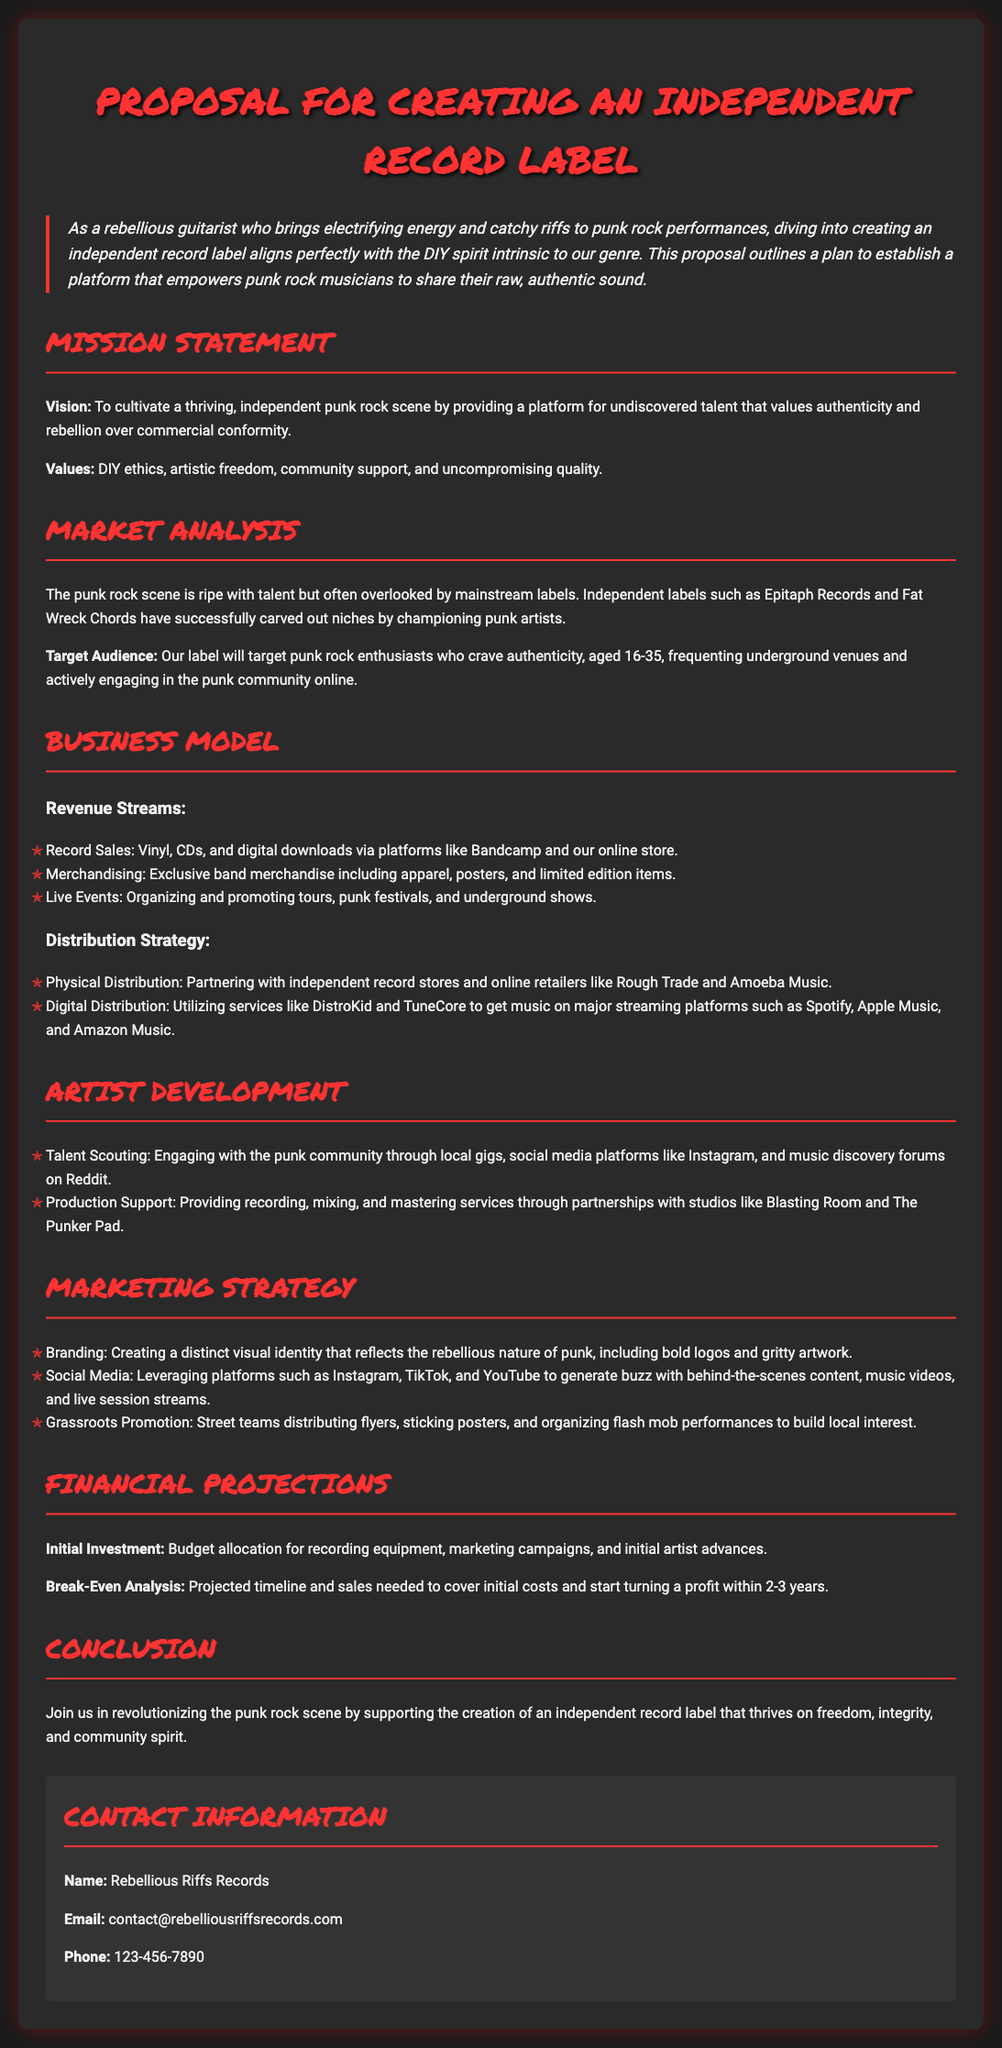What is the main mission of the record label? The mission statement outlines the vision of cultivating an independent punk rock scene with a focus on authenticity and rebellion.
Answer: To cultivate a thriving, independent punk rock scene What are the target audience age range for the label? The document specifies the age range of the target audience looking for authenticity in the punk scene.
Answer: 16-35 Which two independent labels are mentioned in the market analysis? The proposal lists Epitaph Records and Fat Wreck Chords as examples of successful independent labels.
Answer: Epitaph Records and Fat Wreck Chords What revenue stream involves organizing tours and festivals? The business model section specifies that live events generate revenue through organizing and promoting various performances.
Answer: Live Events How will the label utilize digital distribution services? The document states the label plans to employ services that help place music on major streaming platforms as a part of its distribution strategy.
Answer: DistroKid and TuneCore What is emphasized in the values section of the mission statement? The proposal outlines core values that highlight the commitment to artistic freedom and community engagement.
Answer: DIY ethics, artistic freedom, community support, and uncompromising quality What is the initial funding used for according to the financial projections? The financial section details the areas where the initial investment will be allocated for starting the label.
Answer: Recording equipment, marketing campaigns, and initial artist advances What is the tone of the proposal? The overall tone reinforces the DIY spirit and punk rock ethos that the independent label aims to embody.
Answer: Rebellious and passionate What contact method is listed for reaching the label? The contact section provides a single email method for inquiries about the record label.
Answer: contact@rebelliousriffsrecords.com 